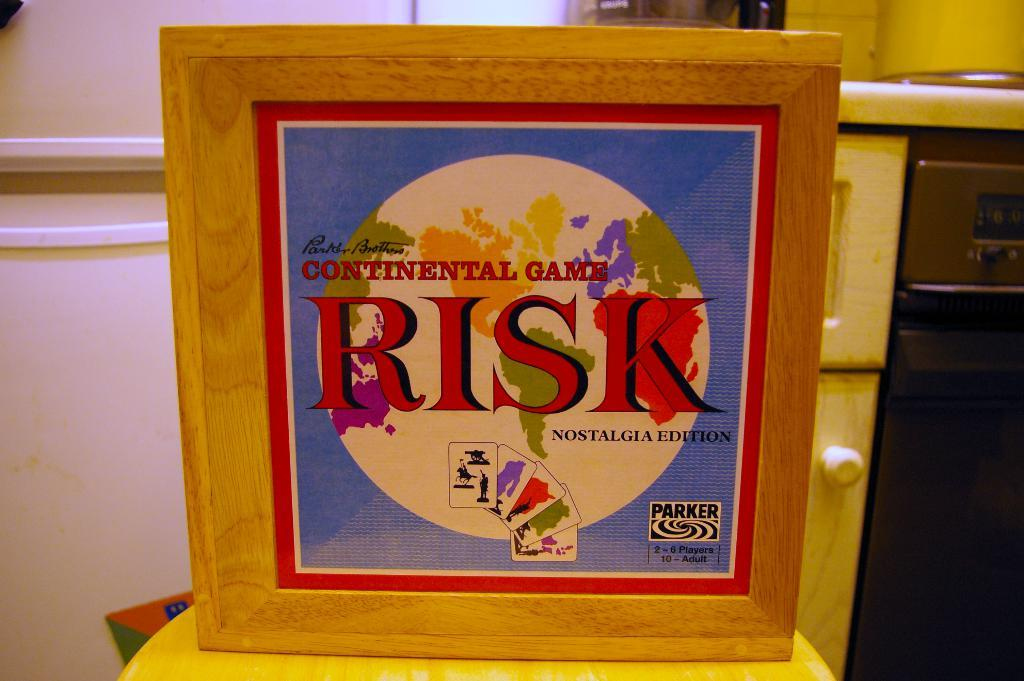Provide a one-sentence caption for the provided image. The Nostalgia Edition of the board game, Risk. 